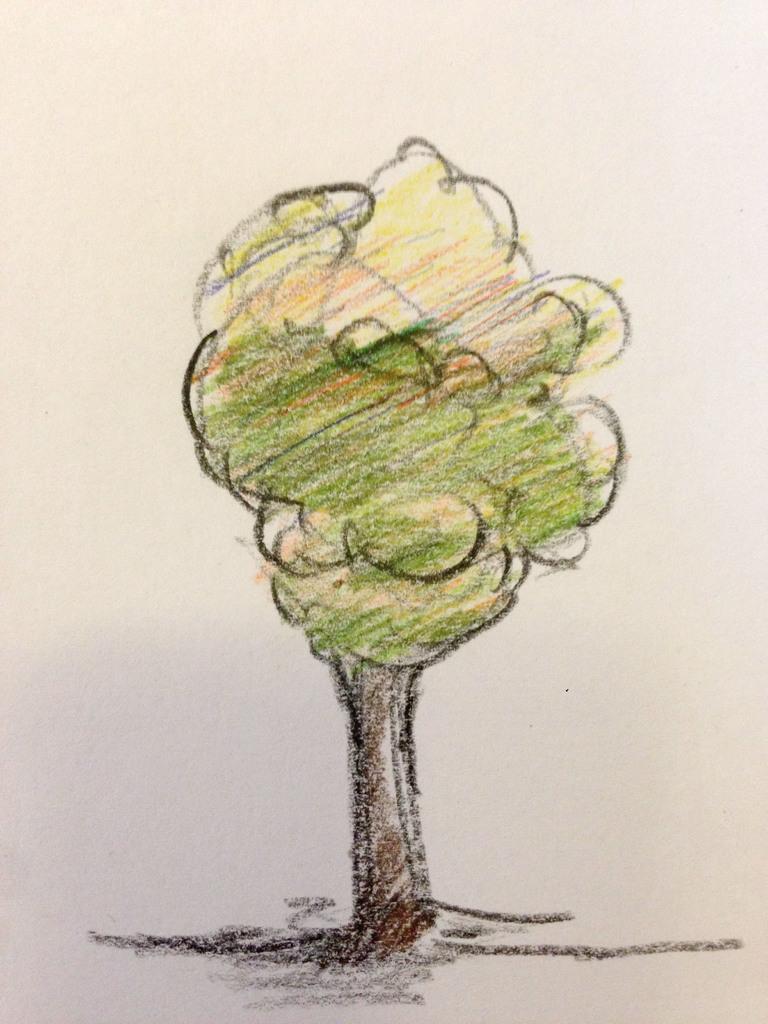Could you give a brief overview of what you see in this image? Here in this picture we can see a paper, on which we can see a tree is drawn and colored with crayons over there. 